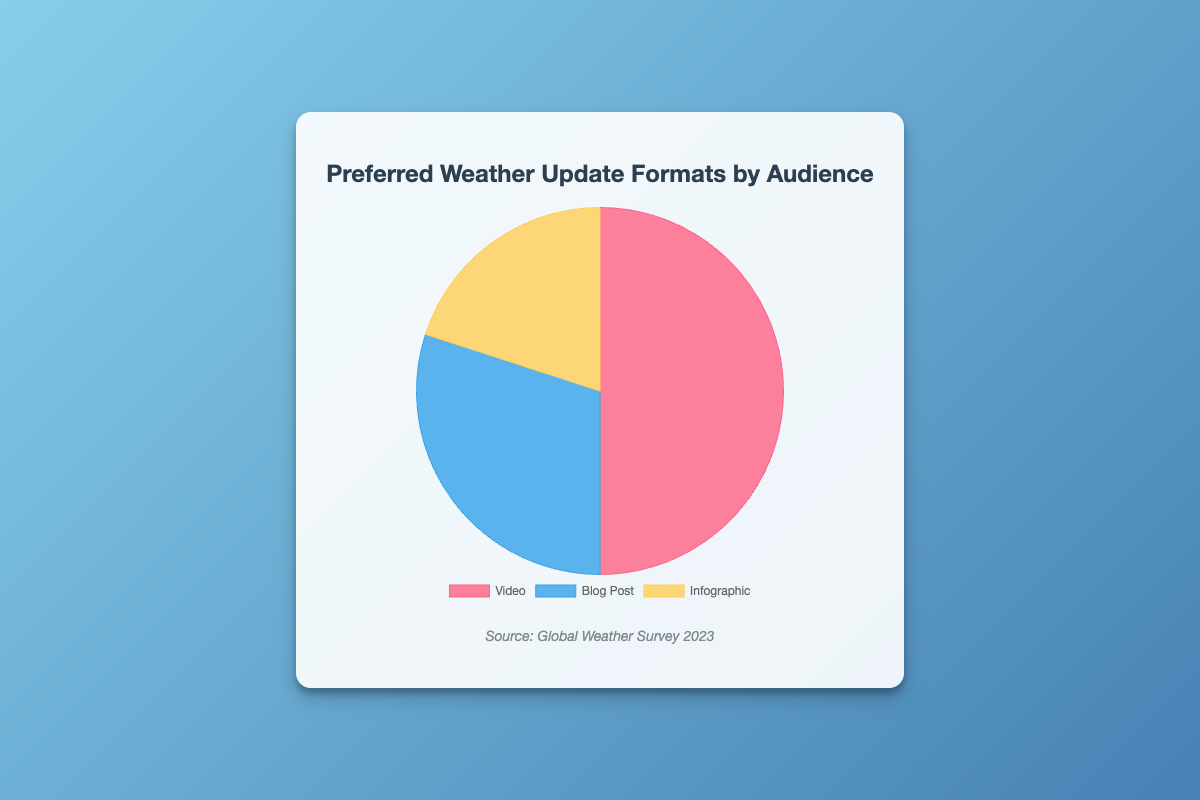What is the most preferred format for weather updates? According to the pie chart, the 'Video' format has the largest portion, representing 50% of the preferences.
Answer: Video Which format has the least preference among the audience? The 'Infographic' format is the smallest portion of the pie chart, representing 20% of the preferences.
Answer: Infographic How much more preferred is the Video format compared to the Blog Post format? The Video format is 50% and the Blog Post format is 30%. The difference is 50% - 30% = 20%.
Answer: 20% What is the combined preference percentage for Blog Posts and Infographics? The preference for Blog Posts is 30% and for Infographics is 20%. Combined, it is 30% + 20% = 50%.
Answer: 50% Which format is preferred by Information Seekers? According to the data provided, Information Seekers prefer the 'Blog Post' format.
Answer: Blog Post What percentage of the audience prefers visual formats (Video + Infographic)? The preference for Video is 50% and for Infographics is 20%. Combined, it is 50% + 20% = 70%.
Answer: 70% How does the pie chart visually represent the difference in preference between Blog Posts and Infographics? The Blog Post section is larger than the Infographic section. The Blog Post accounts for 30%, while Infographic accounts for 20%, showing a clear difference in segment size.
Answer: Blog Post section is larger Which demographic prefers the least preferred format? The least preferred format is 'Infographic,' and the demographic that prefers this format is 'Visual Learners'.
Answer: Visual Learners What is the total preference percentage accounted for by non-visual formats (Blog Posts)? The only non-visual format is Blog Posts, which accounts for 30% of the total preference.
Answer: 30% 